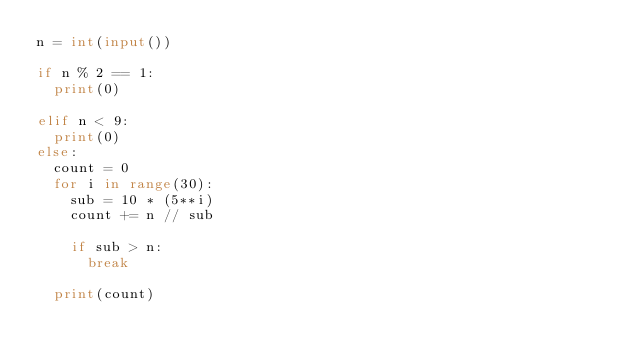Convert code to text. <code><loc_0><loc_0><loc_500><loc_500><_Python_>n = int(input())

if n % 2 == 1:
  print(0)
  
elif n < 9:
  print(0)
else:
  count = 0
  for i in range(30):
    sub = 10 * (5**i)
    count += n // sub
    
    if sub > n:
      break
      
  print(count)
        
  </code> 